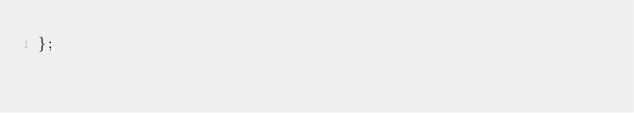<code> <loc_0><loc_0><loc_500><loc_500><_JavaScript_>};
</code> 